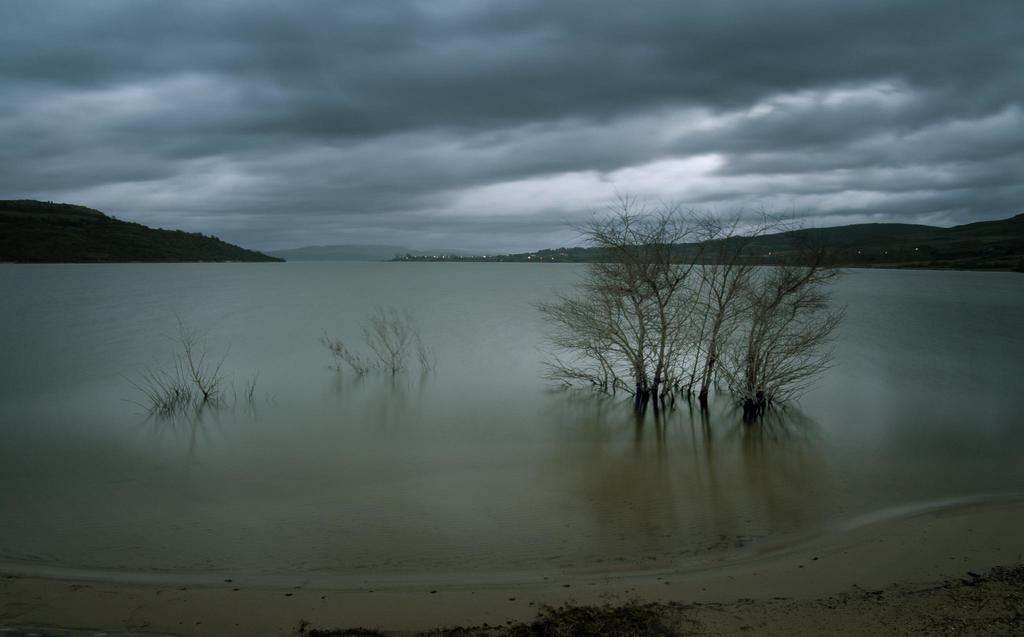What is unique about the trees in the image? The trees are in the water. What can be seen in the distance behind the trees? There are hills visible in the background. What else is visible in the background? The sky is visible in the background. Can you describe the sky in the image? Clouds are present in the sky. Where is the prison located in the image? There is no prison present in the image. What type of crib is visible in the image? There is no crib present in the image. 